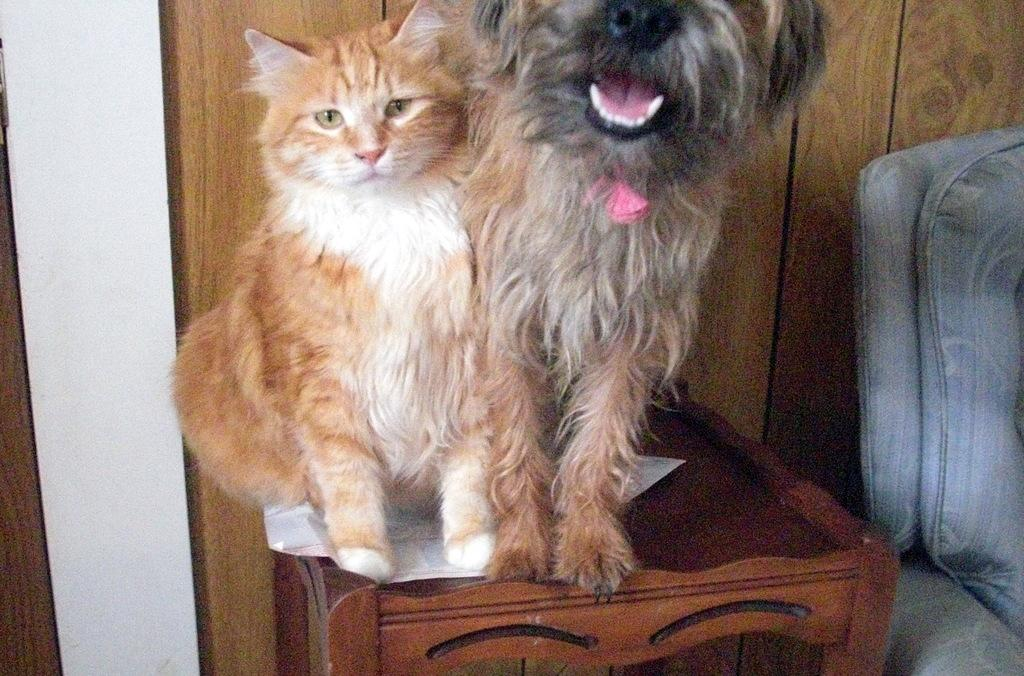What animals can be seen in the image? There is a cat and a dog in the image. Where are the animals located? The animals are on a table in the image. What type of wall is visible in the image? There is a wooden wall in the image. Can you describe the object on the right side of the image? Unfortunately, the facts provided do not specify the nature of the object on the right side of the image. What type of silk is being used by the cat to mark its territory in the image? There is no silk or territorial marking behavior present in the image. The cat and dog are simply on a table, and the image does not depict any silk or territorial behavior. 